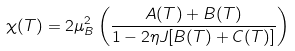<formula> <loc_0><loc_0><loc_500><loc_500>\chi ( T ) = 2 \mu _ { B } ^ { 2 } \left ( \frac { A ( T ) + B ( T ) } { 1 - 2 \eta J [ B ( T ) + C ( T ) ] } \right )</formula> 